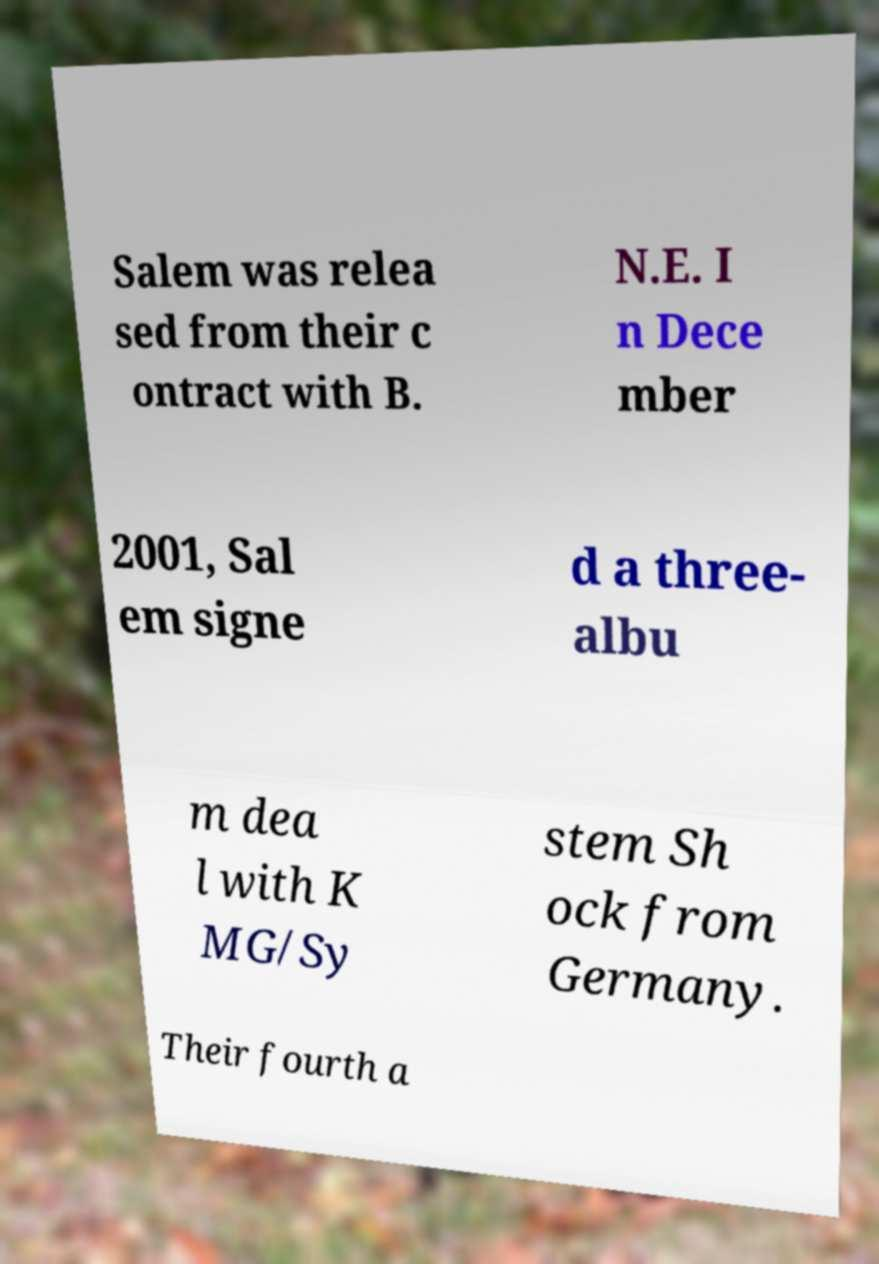For documentation purposes, I need the text within this image transcribed. Could you provide that? Salem was relea sed from their c ontract with B. N.E. I n Dece mber 2001, Sal em signe d a three- albu m dea l with K MG/Sy stem Sh ock from Germany. Their fourth a 